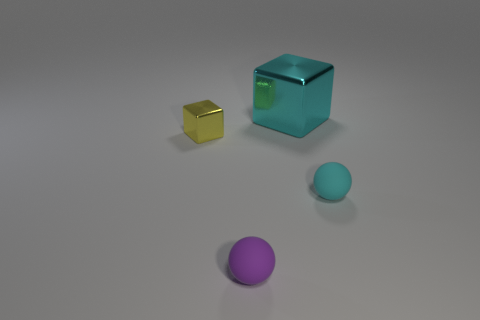Add 3 cyan spheres. How many objects exist? 7 Subtract 0 gray spheres. How many objects are left? 4 Subtract all small rubber balls. Subtract all shiny objects. How many objects are left? 0 Add 3 small cyan balls. How many small cyan balls are left? 4 Add 2 tiny metal blocks. How many tiny metal blocks exist? 3 